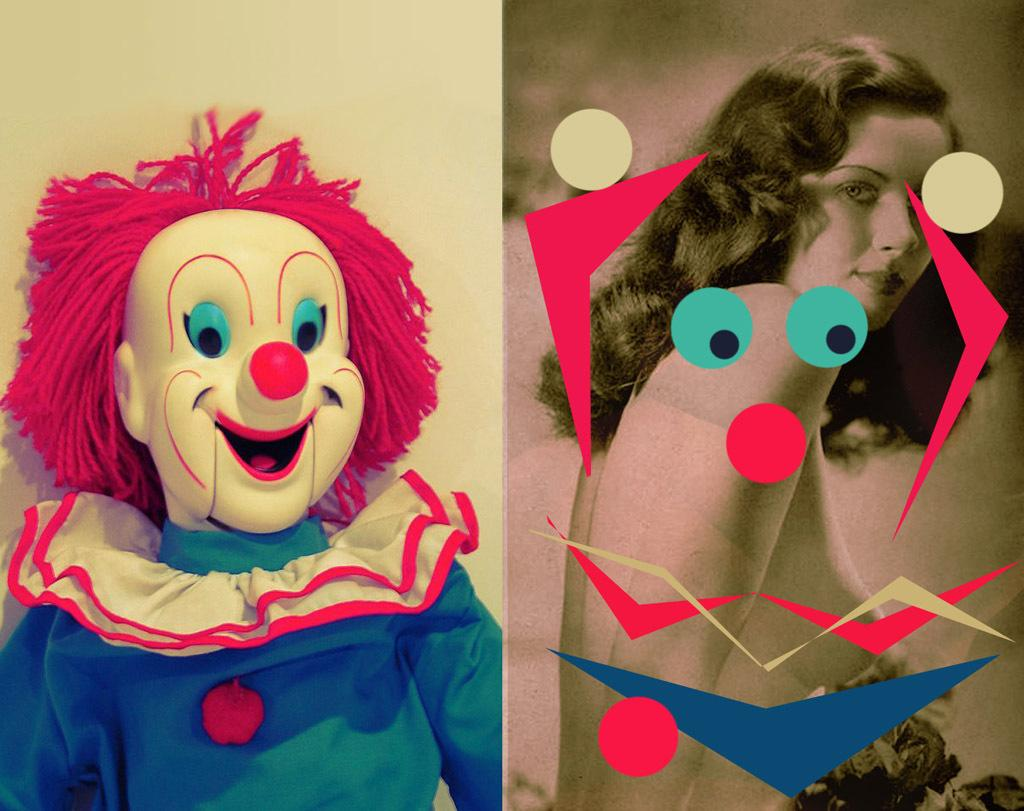How many people are in the group depicted in the image? The image shows a group of people standing together. What are the people in the group doing? The people in the group are holding hands. What type of dirt can be seen on the battlefield in the image? There is no battlefield or dirt present in the image; it features a group of people holding hands. What type of vegetable is being used as a weapon in the image? There is no weapon or vegetable present in the image; it features a group of people holding hands. 